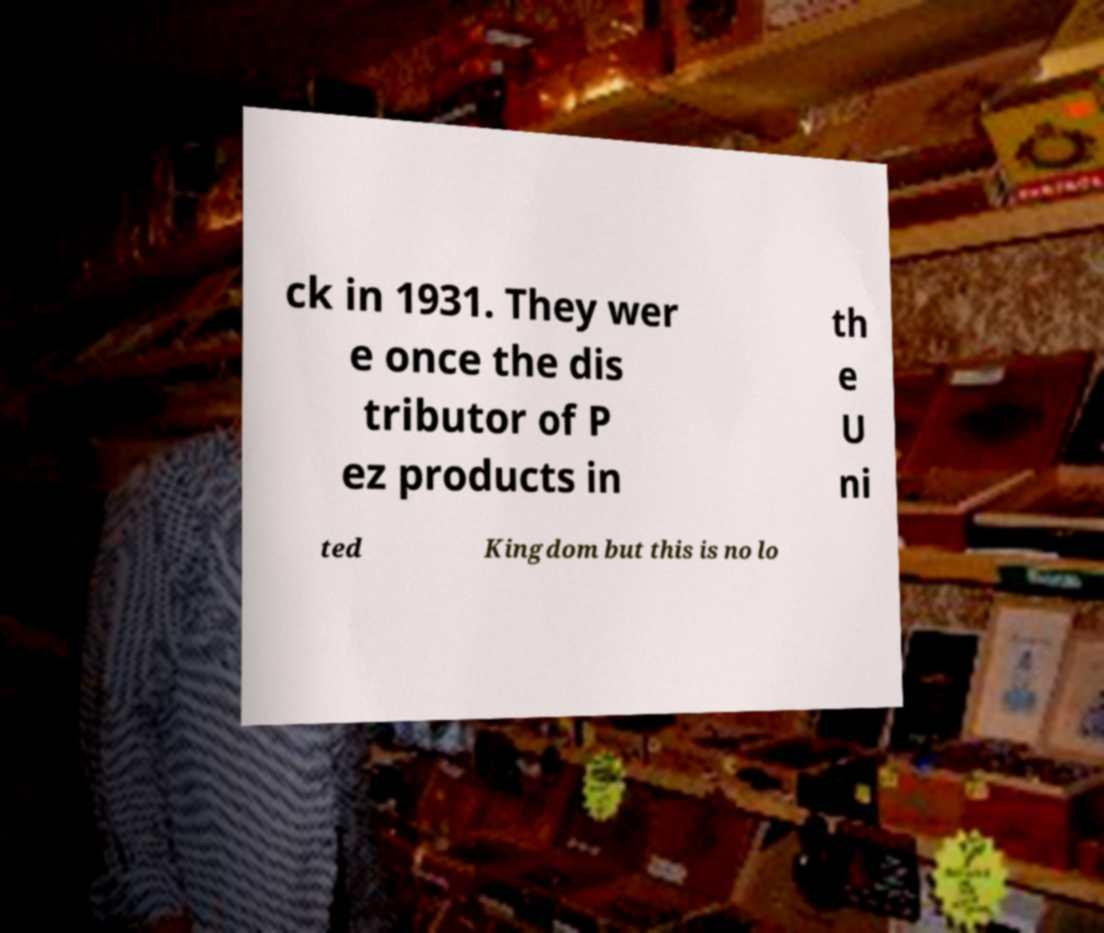Can you accurately transcribe the text from the provided image for me? ck in 1931. They wer e once the dis tributor of P ez products in th e U ni ted Kingdom but this is no lo 